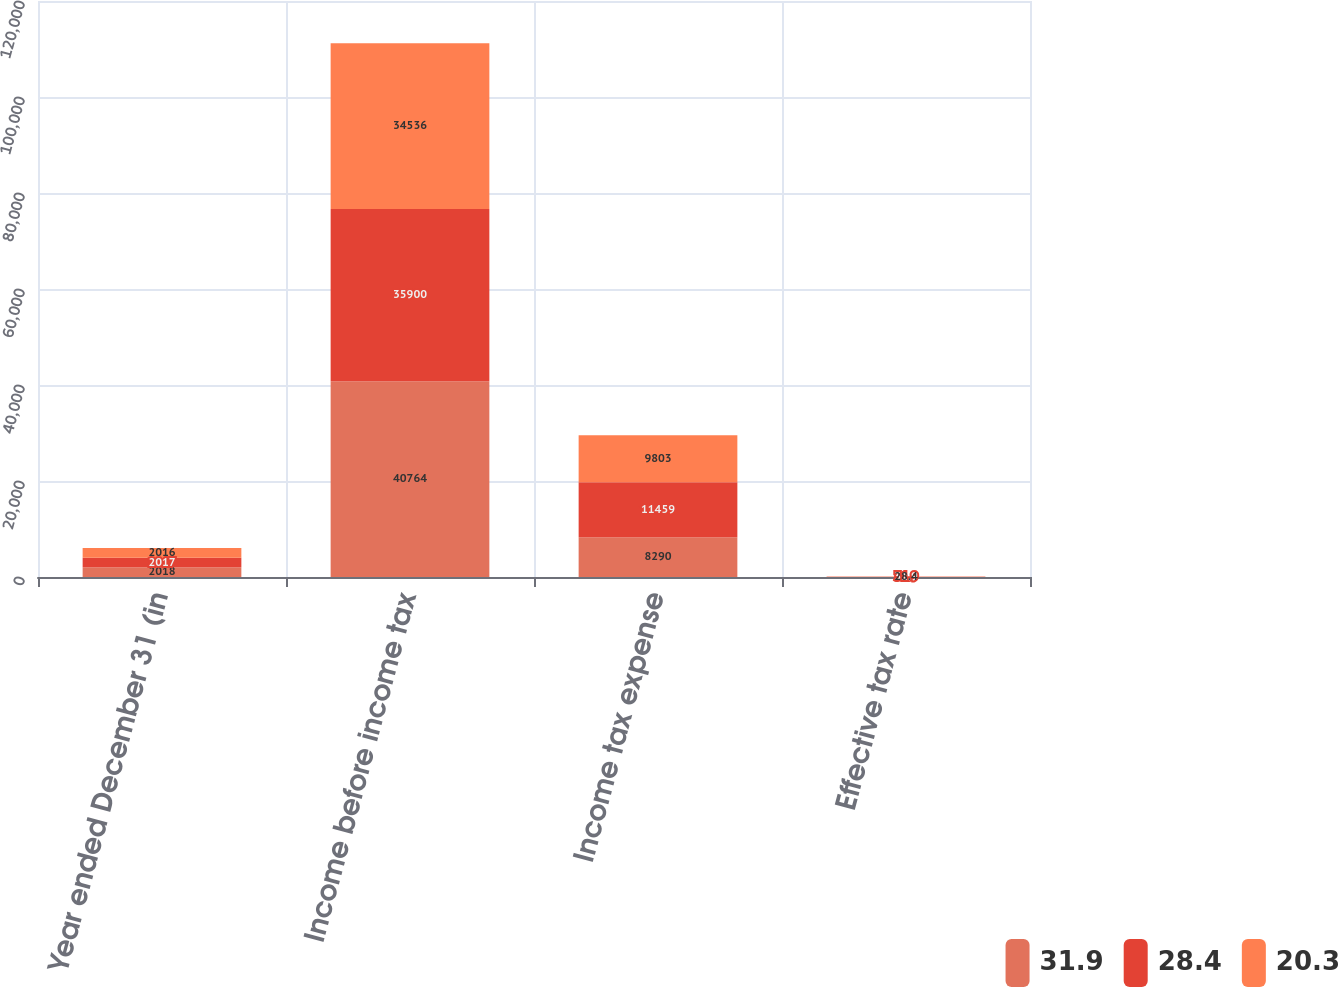Convert chart. <chart><loc_0><loc_0><loc_500><loc_500><stacked_bar_chart><ecel><fcel>Year ended December 31 (in<fcel>Income before income tax<fcel>Income tax expense<fcel>Effective tax rate<nl><fcel>31.9<fcel>2018<fcel>40764<fcel>8290<fcel>20.3<nl><fcel>28.4<fcel>2017<fcel>35900<fcel>11459<fcel>31.9<nl><fcel>20.3<fcel>2016<fcel>34536<fcel>9803<fcel>28.4<nl></chart> 